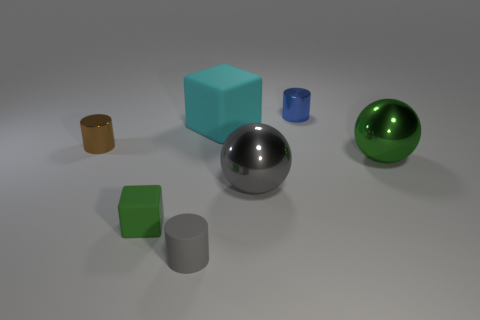There is a object that is the same color as the tiny matte block; what shape is it?
Offer a terse response. Sphere. There is a tiny cylinder that is in front of the tiny green thing; is it the same color as the big shiny sphere that is to the left of the blue metallic cylinder?
Provide a succinct answer. Yes. There is a matte cylinder; is it the same color as the large sphere in front of the green shiny object?
Ensure brevity in your answer.  Yes. There is a blue object that is the same shape as the brown object; what material is it?
Offer a terse response. Metal. Is the green metallic object the same shape as the tiny green matte object?
Your response must be concise. No. There is a green object in front of the green metallic thing; what number of cylinders are to the right of it?
Give a very brief answer. 2. There is a blue object that is the same material as the brown cylinder; what is its shape?
Your answer should be very brief. Cylinder. How many blue objects are either cylinders or metal balls?
Provide a short and direct response. 1. There is a block that is right of the block in front of the large rubber block; is there a matte cylinder that is to the left of it?
Provide a succinct answer. Yes. Are there fewer cubes than objects?
Your response must be concise. Yes. 